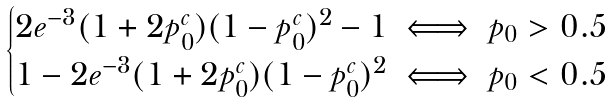<formula> <loc_0><loc_0><loc_500><loc_500>\begin{cases} 2 e ^ { - 3 } ( 1 + 2 p ^ { c } _ { 0 } ) ( 1 - p ^ { c } _ { 0 } ) ^ { 2 } - 1 \iff p _ { 0 } > 0 . 5 \\ 1 - 2 e ^ { - 3 } ( 1 + 2 p ^ { c } _ { 0 } ) ( 1 - p ^ { c } _ { 0 } ) ^ { 2 } \iff p _ { 0 } < 0 . 5 \end{cases}</formula> 